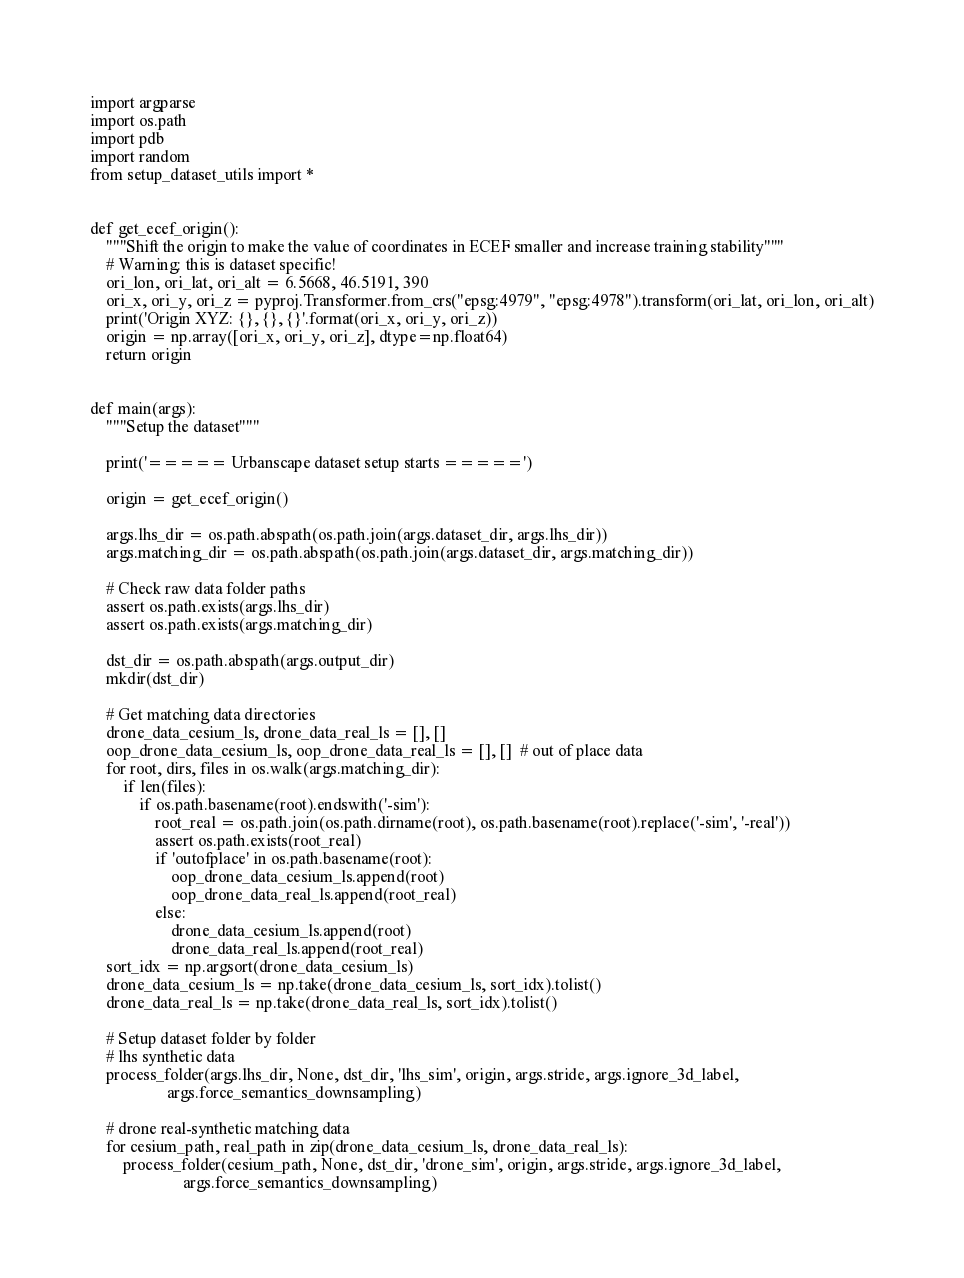<code> <loc_0><loc_0><loc_500><loc_500><_Python_>import argparse
import os.path
import pdb
import random
from setup_dataset_utils import *


def get_ecef_origin():
    """Shift the origin to make the value of coordinates in ECEF smaller and increase training stability"""
    # Warning: this is dataset specific!
    ori_lon, ori_lat, ori_alt = 6.5668, 46.5191, 390
    ori_x, ori_y, ori_z = pyproj.Transformer.from_crs("epsg:4979", "epsg:4978").transform(ori_lat, ori_lon, ori_alt)
    print('Origin XYZ: {}, {}, {}'.format(ori_x, ori_y, ori_z))
    origin = np.array([ori_x, ori_y, ori_z], dtype=np.float64)
    return origin


def main(args):
    """Setup the dataset"""

    print('===== Urbanscape dataset setup starts =====')

    origin = get_ecef_origin()

    args.lhs_dir = os.path.abspath(os.path.join(args.dataset_dir, args.lhs_dir))
    args.matching_dir = os.path.abspath(os.path.join(args.dataset_dir, args.matching_dir))

    # Check raw data folder paths
    assert os.path.exists(args.lhs_dir)
    assert os.path.exists(args.matching_dir)

    dst_dir = os.path.abspath(args.output_dir)
    mkdir(dst_dir)

    # Get matching data directories
    drone_data_cesium_ls, drone_data_real_ls = [], []
    oop_drone_data_cesium_ls, oop_drone_data_real_ls = [], []  # out of place data
    for root, dirs, files in os.walk(args.matching_dir):
        if len(files):
            if os.path.basename(root).endswith('-sim'):
                root_real = os.path.join(os.path.dirname(root), os.path.basename(root).replace('-sim', '-real'))
                assert os.path.exists(root_real)
                if 'outofplace' in os.path.basename(root):
                    oop_drone_data_cesium_ls.append(root)
                    oop_drone_data_real_ls.append(root_real)
                else:
                    drone_data_cesium_ls.append(root)
                    drone_data_real_ls.append(root_real)
    sort_idx = np.argsort(drone_data_cesium_ls)
    drone_data_cesium_ls = np.take(drone_data_cesium_ls, sort_idx).tolist()
    drone_data_real_ls = np.take(drone_data_real_ls, sort_idx).tolist()

    # Setup dataset folder by folder
    # lhs synthetic data
    process_folder(args.lhs_dir, None, dst_dir, 'lhs_sim', origin, args.stride, args.ignore_3d_label,
                   args.force_semantics_downsampling)

    # drone real-synthetic matching data
    for cesium_path, real_path in zip(drone_data_cesium_ls, drone_data_real_ls):
        process_folder(cesium_path, None, dst_dir, 'drone_sim', origin, args.stride, args.ignore_3d_label,
                       args.force_semantics_downsampling)</code> 